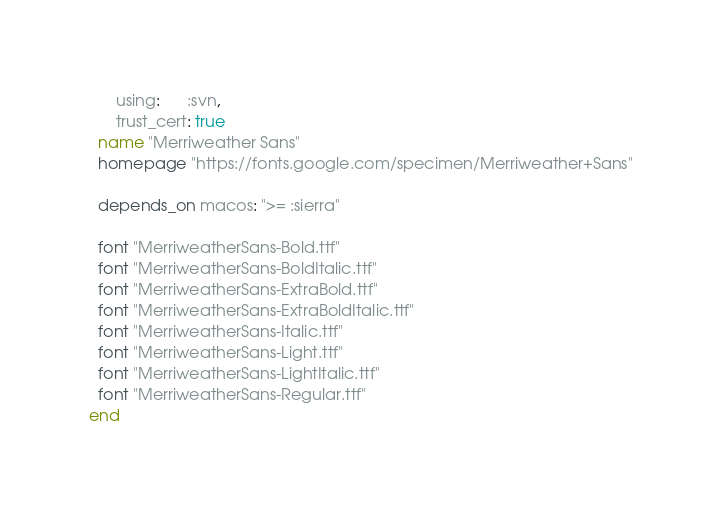<code> <loc_0><loc_0><loc_500><loc_500><_Ruby_>      using:      :svn,
      trust_cert: true
  name "Merriweather Sans"
  homepage "https://fonts.google.com/specimen/Merriweather+Sans"

  depends_on macos: ">= :sierra"

  font "MerriweatherSans-Bold.ttf"
  font "MerriweatherSans-BoldItalic.ttf"
  font "MerriweatherSans-ExtraBold.ttf"
  font "MerriweatherSans-ExtraBoldItalic.ttf"
  font "MerriweatherSans-Italic.ttf"
  font "MerriweatherSans-Light.ttf"
  font "MerriweatherSans-LightItalic.ttf"
  font "MerriweatherSans-Regular.ttf"
end
</code> 